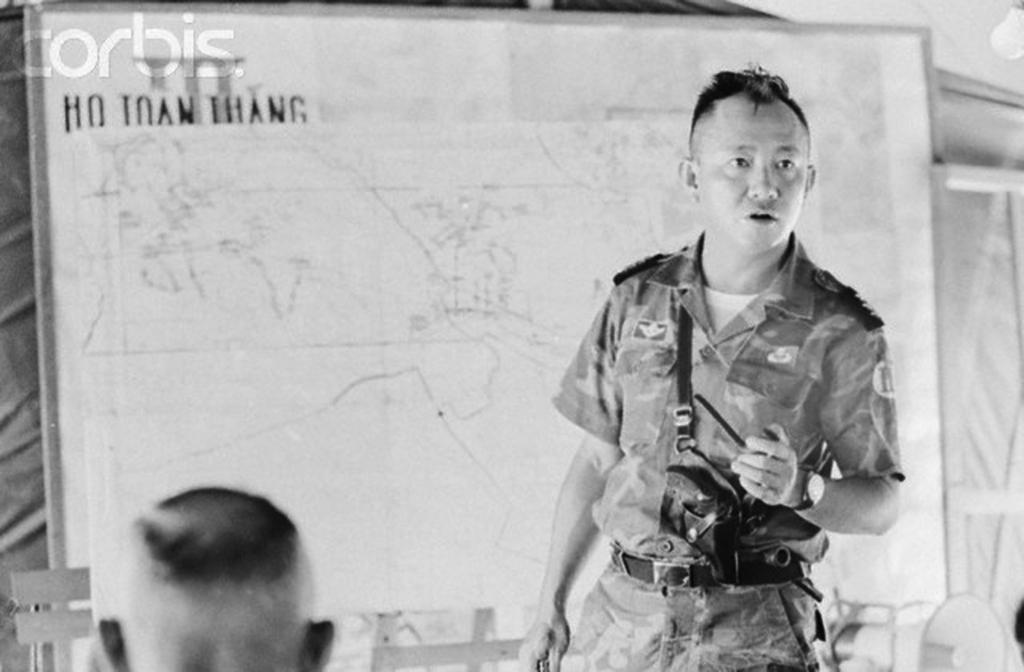Please provide a concise description of this image. On the right side of the image we can see a man standing. He is wearing a uniform. In the background there is a board. At the bottom there is a person and we can see a light. 